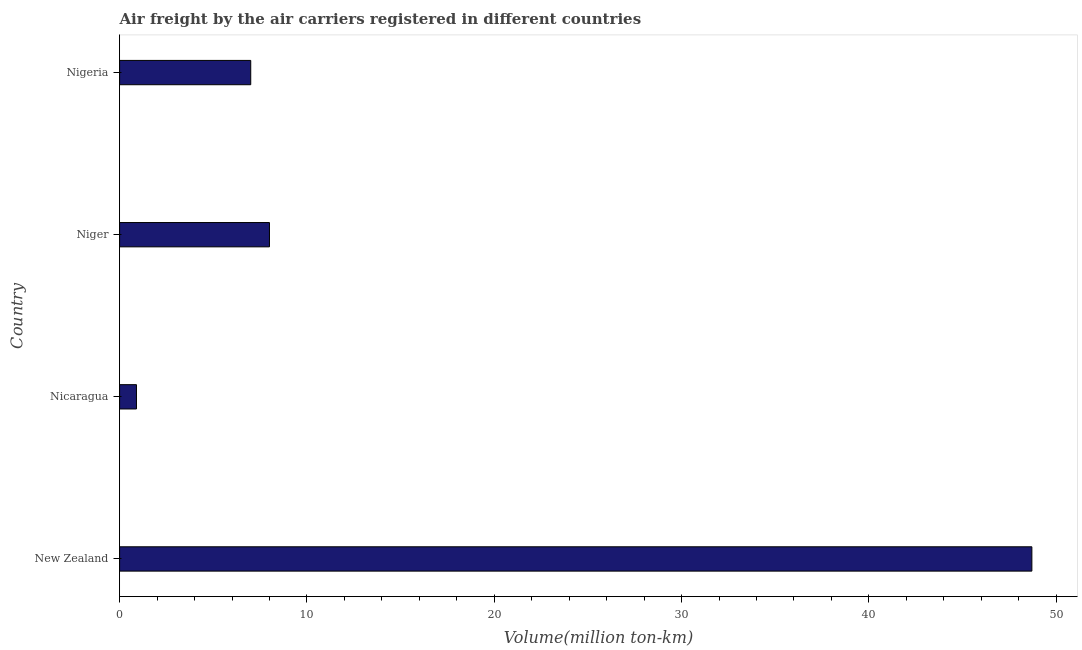Does the graph contain any zero values?
Offer a very short reply. No. Does the graph contain grids?
Provide a short and direct response. No. What is the title of the graph?
Provide a short and direct response. Air freight by the air carriers registered in different countries. What is the label or title of the X-axis?
Your answer should be compact. Volume(million ton-km). What is the label or title of the Y-axis?
Your response must be concise. Country. What is the air freight in Nicaragua?
Your answer should be very brief. 0.9. Across all countries, what is the maximum air freight?
Offer a terse response. 48.7. Across all countries, what is the minimum air freight?
Your response must be concise. 0.9. In which country was the air freight maximum?
Provide a short and direct response. New Zealand. In which country was the air freight minimum?
Give a very brief answer. Nicaragua. What is the sum of the air freight?
Your answer should be compact. 64.6. What is the difference between the air freight in New Zealand and Nicaragua?
Offer a terse response. 47.8. What is the average air freight per country?
Keep it short and to the point. 16.15. What is the median air freight?
Your answer should be compact. 7.5. What is the ratio of the air freight in New Zealand to that in Nicaragua?
Provide a short and direct response. 54.11. Is the air freight in Nicaragua less than that in Niger?
Your answer should be very brief. Yes. What is the difference between the highest and the second highest air freight?
Offer a very short reply. 40.7. Is the sum of the air freight in New Zealand and Nicaragua greater than the maximum air freight across all countries?
Keep it short and to the point. Yes. What is the difference between the highest and the lowest air freight?
Provide a short and direct response. 47.8. How many bars are there?
Your response must be concise. 4. Are all the bars in the graph horizontal?
Provide a short and direct response. Yes. How many countries are there in the graph?
Ensure brevity in your answer.  4. What is the Volume(million ton-km) in New Zealand?
Ensure brevity in your answer.  48.7. What is the Volume(million ton-km) in Nicaragua?
Keep it short and to the point. 0.9. What is the difference between the Volume(million ton-km) in New Zealand and Nicaragua?
Keep it short and to the point. 47.8. What is the difference between the Volume(million ton-km) in New Zealand and Niger?
Provide a short and direct response. 40.7. What is the difference between the Volume(million ton-km) in New Zealand and Nigeria?
Provide a succinct answer. 41.7. What is the difference between the Volume(million ton-km) in Nicaragua and Niger?
Offer a terse response. -7.1. What is the difference between the Volume(million ton-km) in Nicaragua and Nigeria?
Your response must be concise. -6.1. What is the difference between the Volume(million ton-km) in Niger and Nigeria?
Your answer should be compact. 1. What is the ratio of the Volume(million ton-km) in New Zealand to that in Nicaragua?
Keep it short and to the point. 54.11. What is the ratio of the Volume(million ton-km) in New Zealand to that in Niger?
Offer a terse response. 6.09. What is the ratio of the Volume(million ton-km) in New Zealand to that in Nigeria?
Provide a short and direct response. 6.96. What is the ratio of the Volume(million ton-km) in Nicaragua to that in Niger?
Ensure brevity in your answer.  0.11. What is the ratio of the Volume(million ton-km) in Nicaragua to that in Nigeria?
Make the answer very short. 0.13. What is the ratio of the Volume(million ton-km) in Niger to that in Nigeria?
Your response must be concise. 1.14. 